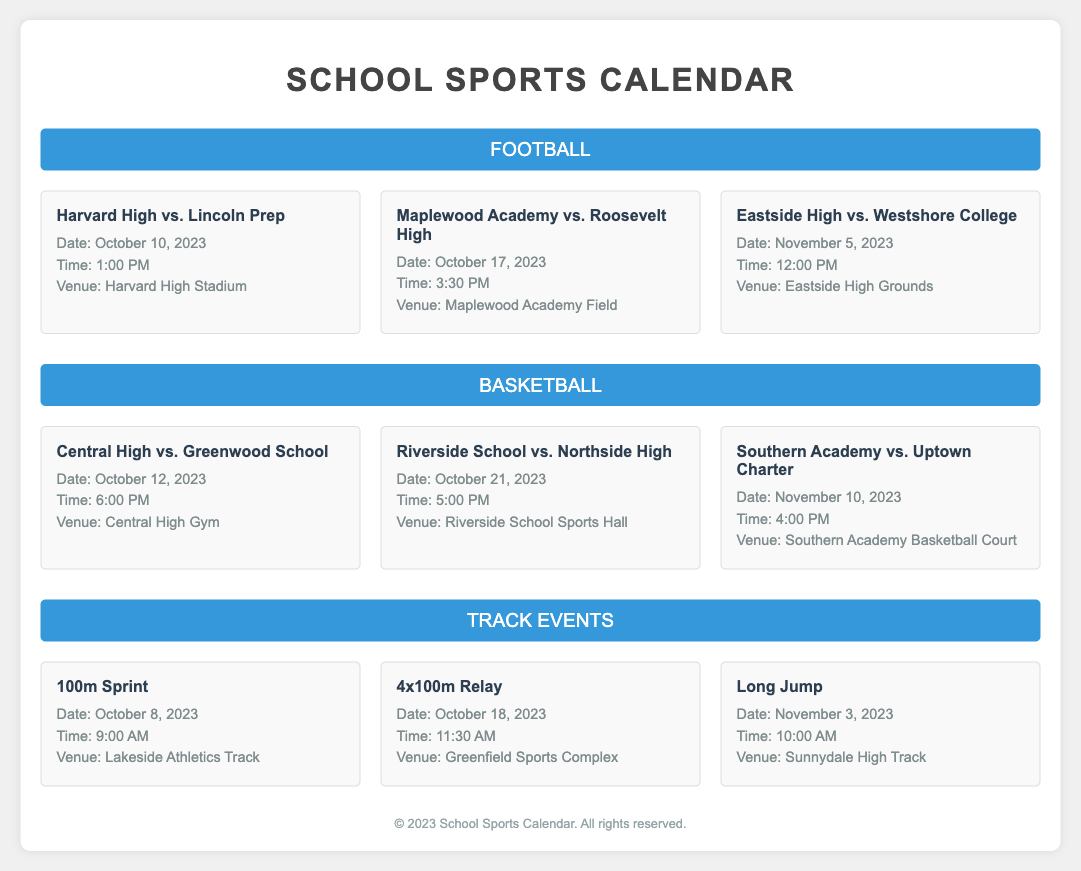What is the date of the first football game? The first football game listed is between Harvard High and Lincoln Prep, scheduled for October 10, 2023.
Answer: October 10, 2023 What time is the basketball game between Riverside School and Northside High? The game between Riverside School and Northside High is scheduled to start at 5:00 PM on October 21, 2023.
Answer: 5:00 PM Where will the 100m Sprint track event be held? The 100m Sprint event is set to take place at Lakeside Athletics Track.
Answer: Lakeside Athletics Track Which school is playing against Southern Academy in basketball? Southern Academy is scheduled to play against Uptown Charter on November 10, 2023.
Answer: Uptown Charter How many football games are listed in the document? There are three football games detailed in the document.
Answer: 3 What is the venue for the Long Jump event? The Long Jump event is taking place at Sunnydale High Track.
Answer: Sunnydale High Track When is the 4x100m Relay scheduled? The 4x100m Relay is scheduled for October 18, 2023, at 11:30 AM.
Answer: October 18, 2023 Which school has a football game on November 5, 2023? Eastside High is playing against Westshore College on November 5, 2023.
Answer: Eastside High What color is the Football section title? The Football section title background is colored in blue (#3498db).
Answer: Blue 